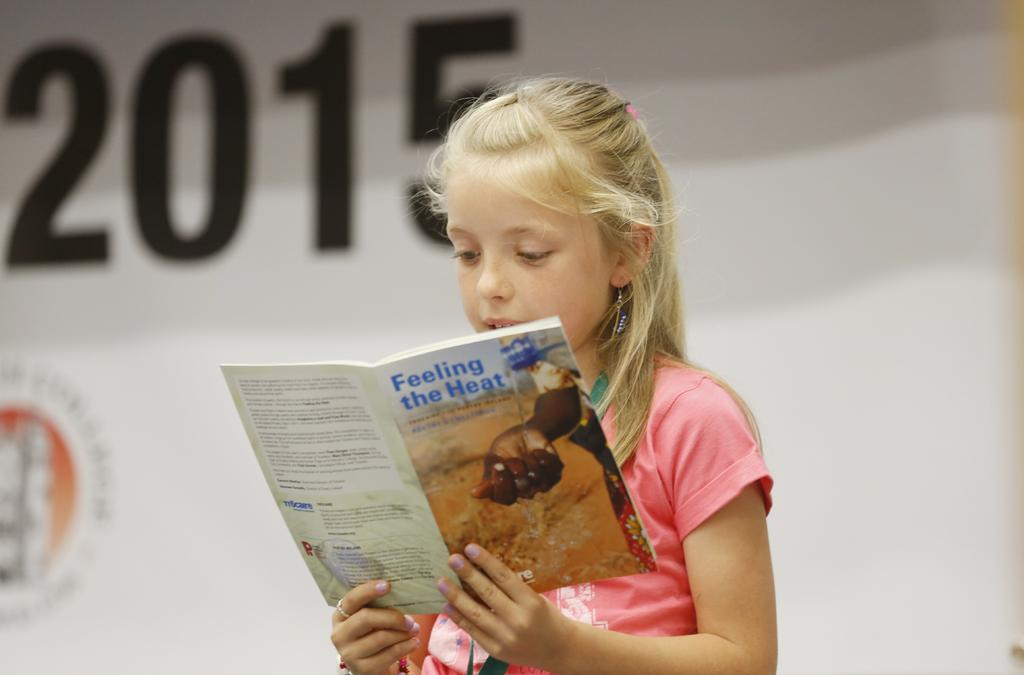Who is the main subject in the image? There is a girl in the image. What is the girl wearing? The girl is wearing clothes, earrings, and a finger ring. What is the girl holding in her hand? The girl is holding a book in her hand. What can be seen in the image besides the girl? There is text visible in the image. How would you describe the background of the image? The background of the image is slightly blurred. What type of frame is used to stitch the girl's clothes in the image? There is no mention of a frame or stitching in the image; the girl's clothes are simply described as being worn. How does the girl care for the book she is holding in the image? The image does not show the girl interacting with the book in any way that suggests she is caring for it. 